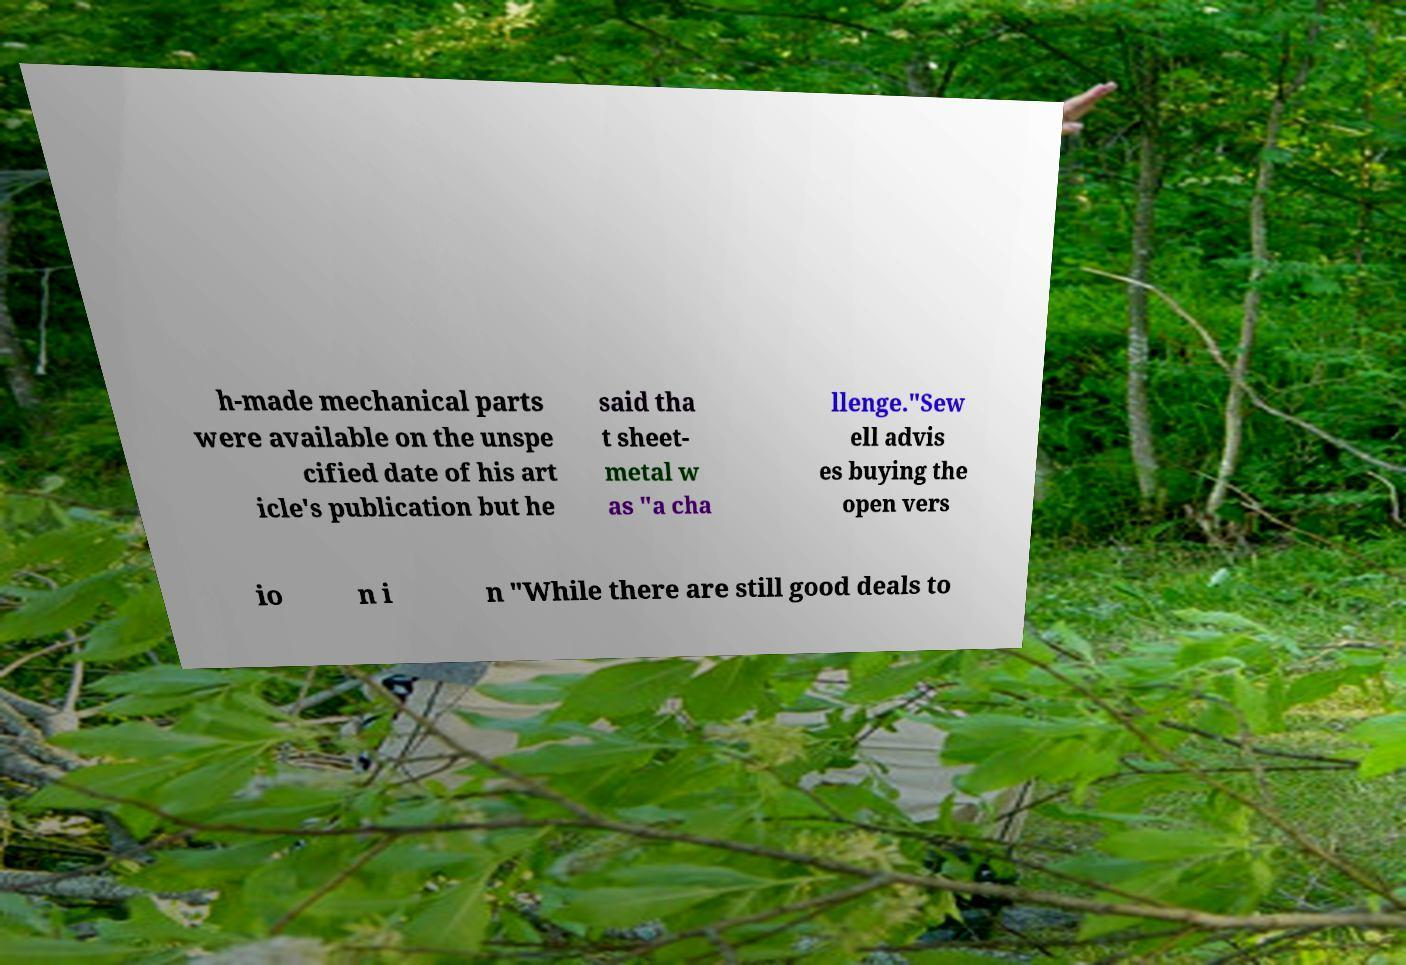There's text embedded in this image that I need extracted. Can you transcribe it verbatim? h-made mechanical parts were available on the unspe cified date of his art icle's publication but he said tha t sheet- metal w as "a cha llenge."Sew ell advis es buying the open vers io n i n "While there are still good deals to 